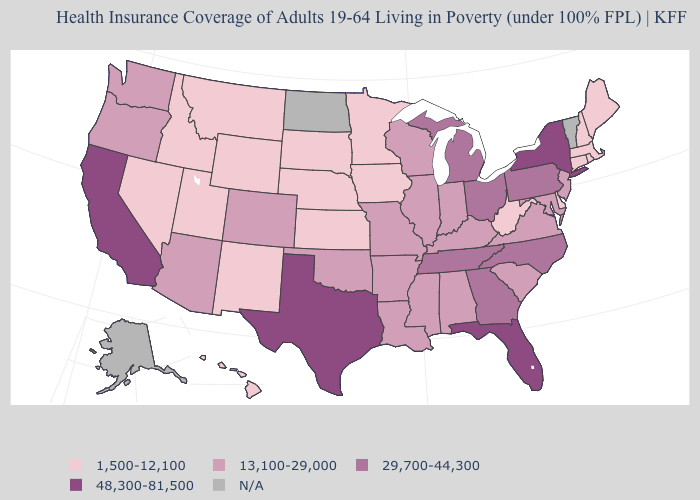Does Delaware have the lowest value in the USA?
Keep it brief. Yes. What is the value of Arkansas?
Be succinct. 13,100-29,000. What is the value of North Carolina?
Short answer required. 29,700-44,300. Does Kansas have the lowest value in the MidWest?
Quick response, please. Yes. What is the lowest value in states that border Texas?
Write a very short answer. 1,500-12,100. What is the highest value in the West ?
Give a very brief answer. 48,300-81,500. What is the highest value in the Northeast ?
Short answer required. 48,300-81,500. What is the value of Louisiana?
Concise answer only. 13,100-29,000. Name the states that have a value in the range 13,100-29,000?
Short answer required. Alabama, Arizona, Arkansas, Colorado, Illinois, Indiana, Kentucky, Louisiana, Maryland, Mississippi, Missouri, New Jersey, Oklahoma, Oregon, South Carolina, Virginia, Washington, Wisconsin. Does West Virginia have the lowest value in the USA?
Short answer required. Yes. How many symbols are there in the legend?
Quick response, please. 5. Which states have the lowest value in the Northeast?
Concise answer only. Connecticut, Maine, Massachusetts, New Hampshire, Rhode Island. 